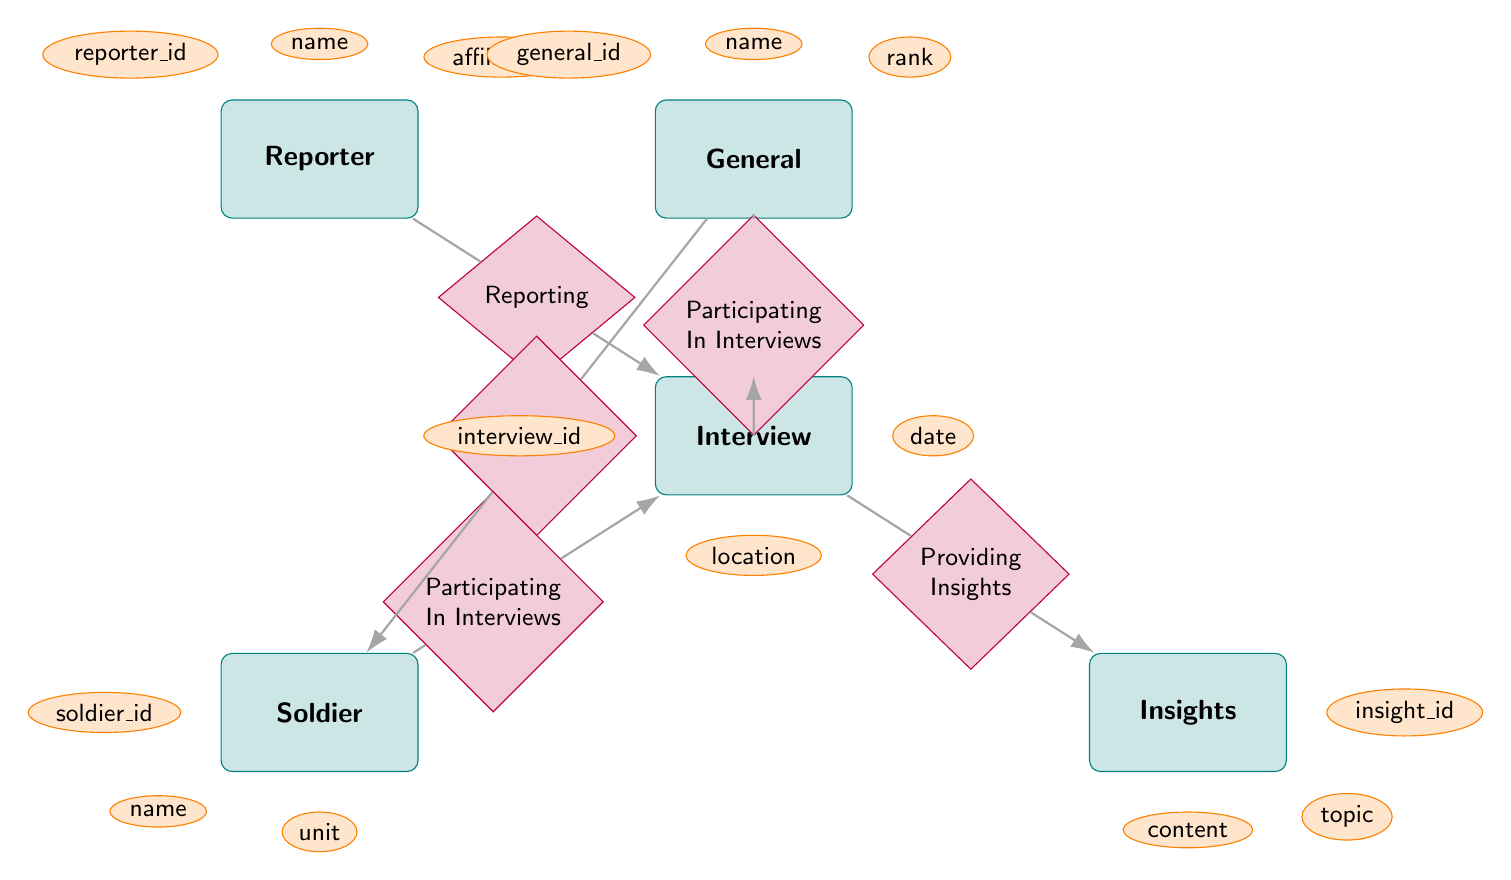What entities are present in the diagram? The diagram includes five entities: Reporter, General, Soldier, Interview, and Insights.
Answer: Reporter, General, Soldier, Interview, Insights How many attributes does the General entity have? The General entity has three attributes: general_id, name, and rank.
Answer: 3 What relationship connects the General to the Soldier? The relationship that connects the General to the Soldier is "Commanding."
Answer: Commanding Which entity is connected to "Providing Insights"? The entity connected to "Providing Insights" is "Interview."
Answer: Interview How many different relationships are depicted in this diagram? There are five relationships in total: Reporting, Commanding, Participating In Interviews (from both General and Soldier), and Providing Insights.
Answer: 5 What attribute can be used to identify a Reporter? The attribute that can be used to identify a Reporter is "reporter_id."
Answer: reporter_id Which entities participate in the Interviews? The entities that participate in Interviews are General and Soldier.
Answer: General, Soldier What is the relationship type between Interview and Insights? The relationship type between Interview and Insights is "Providing Insights."
Answer: Providing Insights Which entity provides insights during an interview? The entity that provides insights during an interview is "Interview."
Answer: Interview 